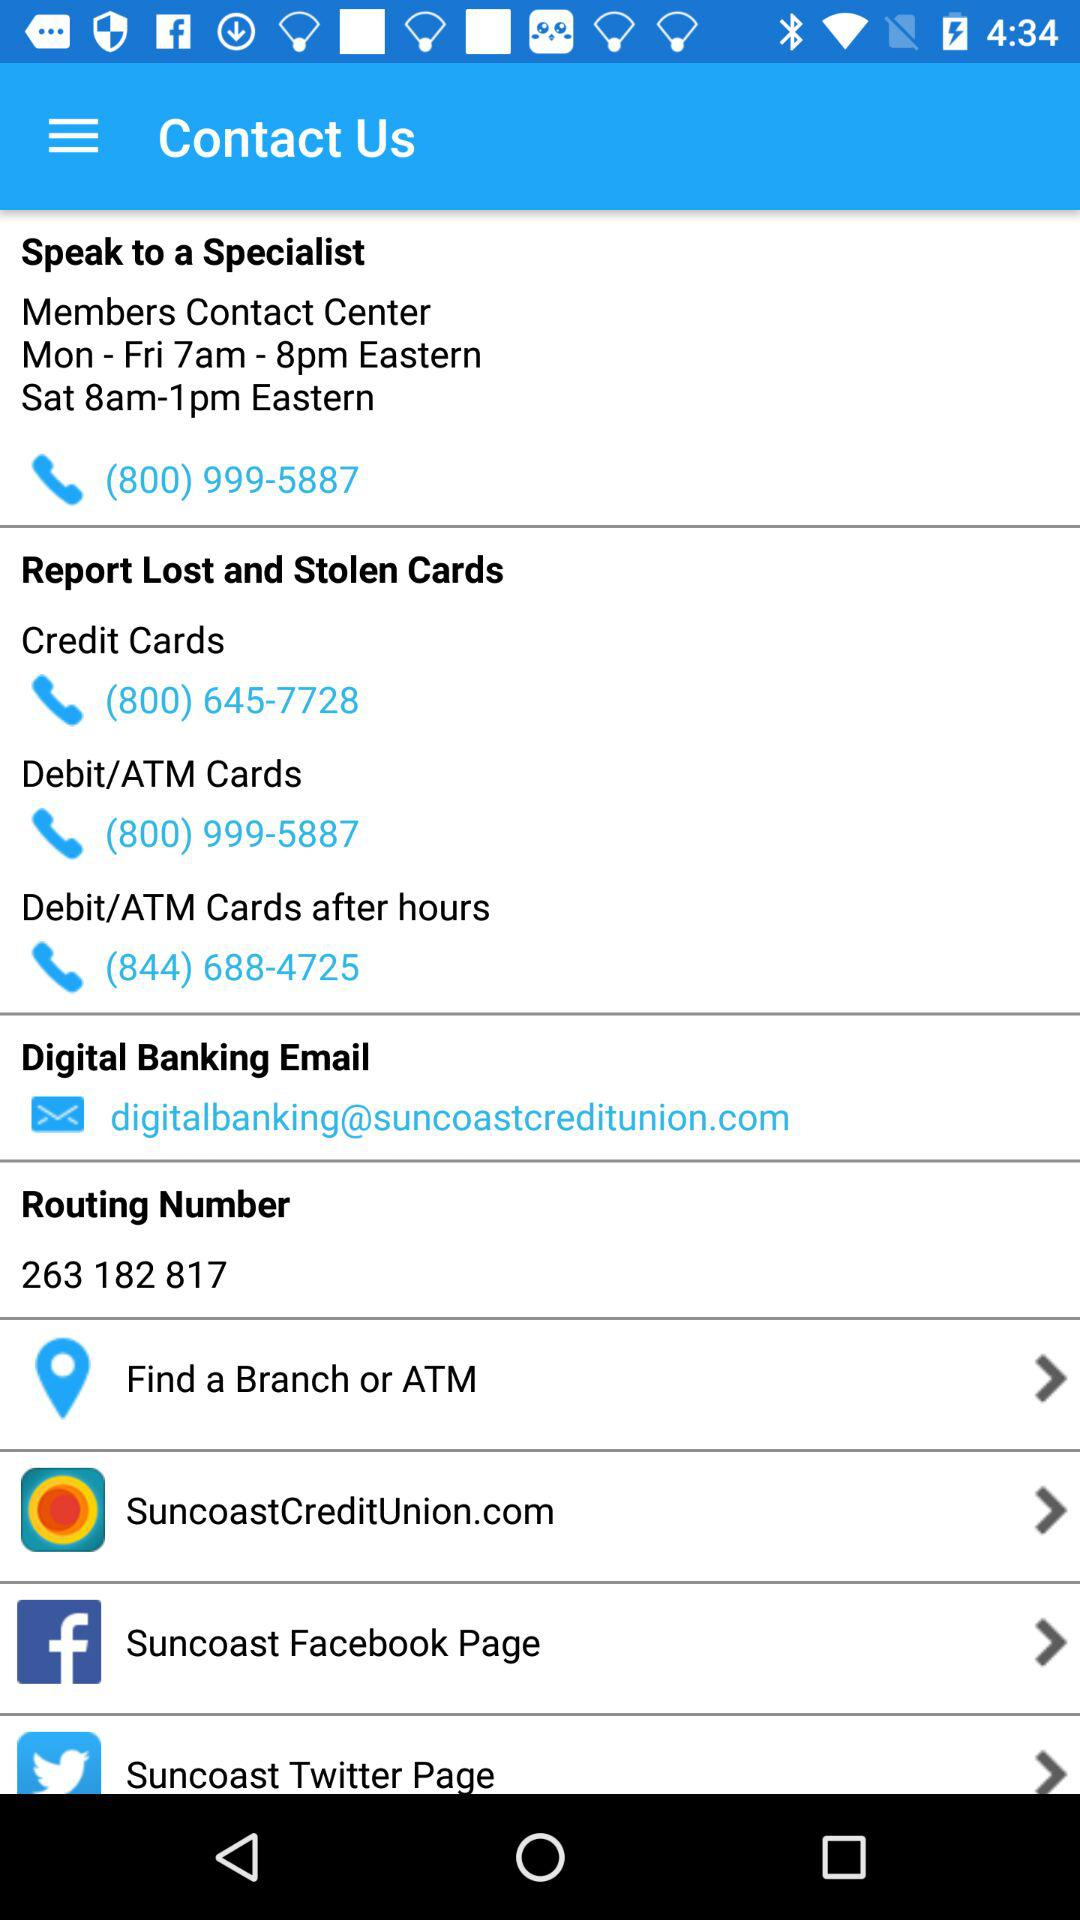What is the contact number to report stolen credit cards? The contact number is (800) 645-7728. 